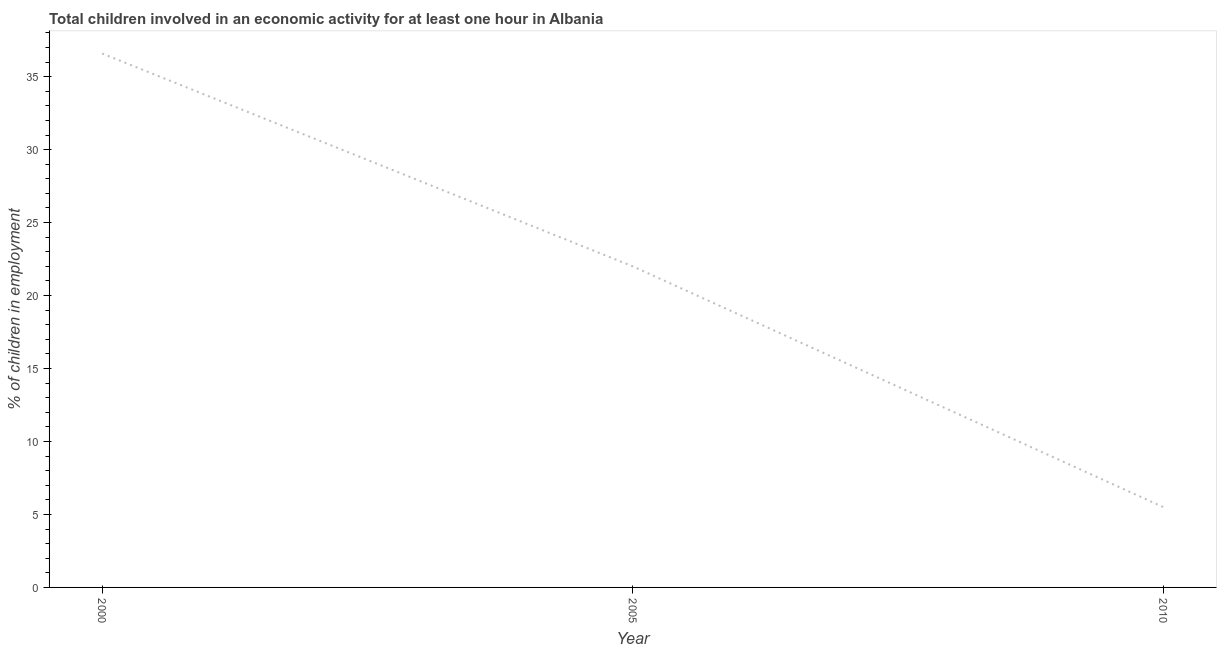What is the percentage of children in employment in 2005?
Your answer should be very brief. 22. Across all years, what is the maximum percentage of children in employment?
Ensure brevity in your answer.  36.59. Across all years, what is the minimum percentage of children in employment?
Make the answer very short. 5.5. In which year was the percentage of children in employment minimum?
Ensure brevity in your answer.  2010. What is the sum of the percentage of children in employment?
Provide a short and direct response. 64.09. What is the difference between the percentage of children in employment in 2000 and 2005?
Your answer should be compact. 14.59. What is the average percentage of children in employment per year?
Your answer should be compact. 21.36. What is the median percentage of children in employment?
Offer a terse response. 22. What is the ratio of the percentage of children in employment in 2005 to that in 2010?
Ensure brevity in your answer.  4. Is the percentage of children in employment in 2000 less than that in 2005?
Ensure brevity in your answer.  No. Is the difference between the percentage of children in employment in 2000 and 2010 greater than the difference between any two years?
Ensure brevity in your answer.  Yes. What is the difference between the highest and the second highest percentage of children in employment?
Keep it short and to the point. 14.59. Is the sum of the percentage of children in employment in 2000 and 2010 greater than the maximum percentage of children in employment across all years?
Your answer should be very brief. Yes. What is the difference between the highest and the lowest percentage of children in employment?
Provide a short and direct response. 31.09. In how many years, is the percentage of children in employment greater than the average percentage of children in employment taken over all years?
Provide a succinct answer. 2. How many years are there in the graph?
Offer a terse response. 3. Are the values on the major ticks of Y-axis written in scientific E-notation?
Your answer should be compact. No. Does the graph contain any zero values?
Provide a short and direct response. No. What is the title of the graph?
Your response must be concise. Total children involved in an economic activity for at least one hour in Albania. What is the label or title of the Y-axis?
Provide a succinct answer. % of children in employment. What is the % of children in employment of 2000?
Ensure brevity in your answer.  36.59. What is the % of children in employment in 2005?
Your answer should be very brief. 22. What is the difference between the % of children in employment in 2000 and 2005?
Provide a succinct answer. 14.59. What is the difference between the % of children in employment in 2000 and 2010?
Make the answer very short. 31.09. What is the difference between the % of children in employment in 2005 and 2010?
Provide a succinct answer. 16.5. What is the ratio of the % of children in employment in 2000 to that in 2005?
Make the answer very short. 1.66. What is the ratio of the % of children in employment in 2000 to that in 2010?
Offer a very short reply. 6.65. 